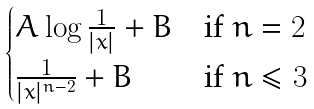<formula> <loc_0><loc_0><loc_500><loc_500>\begin{cases} A \log \frac { 1 } { | x | } + B & \text {if $n=2$} \\ \frac { 1 } { | x | ^ { n - 2 } } + B & \text {if $n\leq 3$} \end{cases}</formula> 